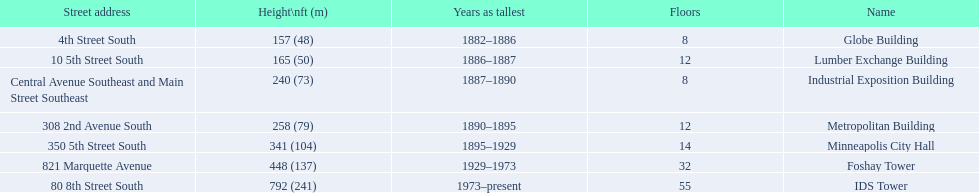Is the metropolitan building or the lumber exchange building taller? Metropolitan Building. 